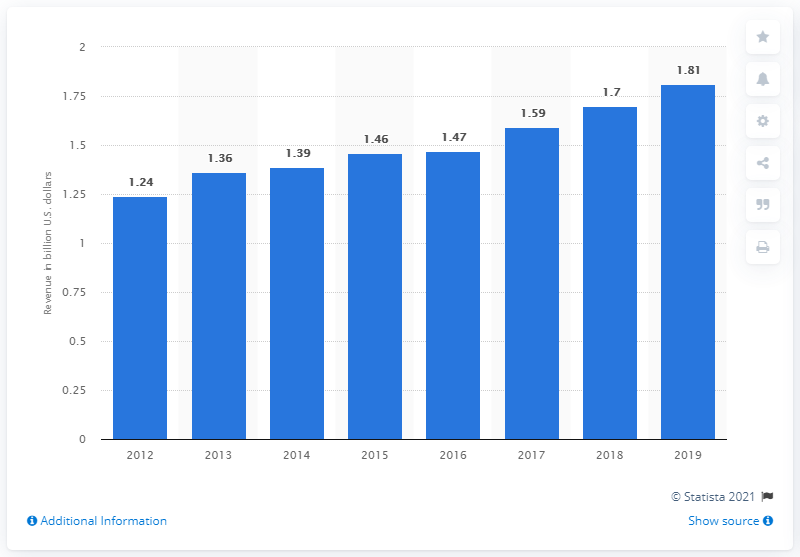Mention a couple of crucial points in this snapshot. UniFirst Corporation's annual revenue for the fiscal year of 2019 was 1.81 billion dollars. 